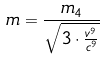Convert formula to latex. <formula><loc_0><loc_0><loc_500><loc_500>m = \frac { m _ { 4 } } { \sqrt { 3 \cdot \frac { v ^ { 9 } } { c ^ { 9 } } } }</formula> 